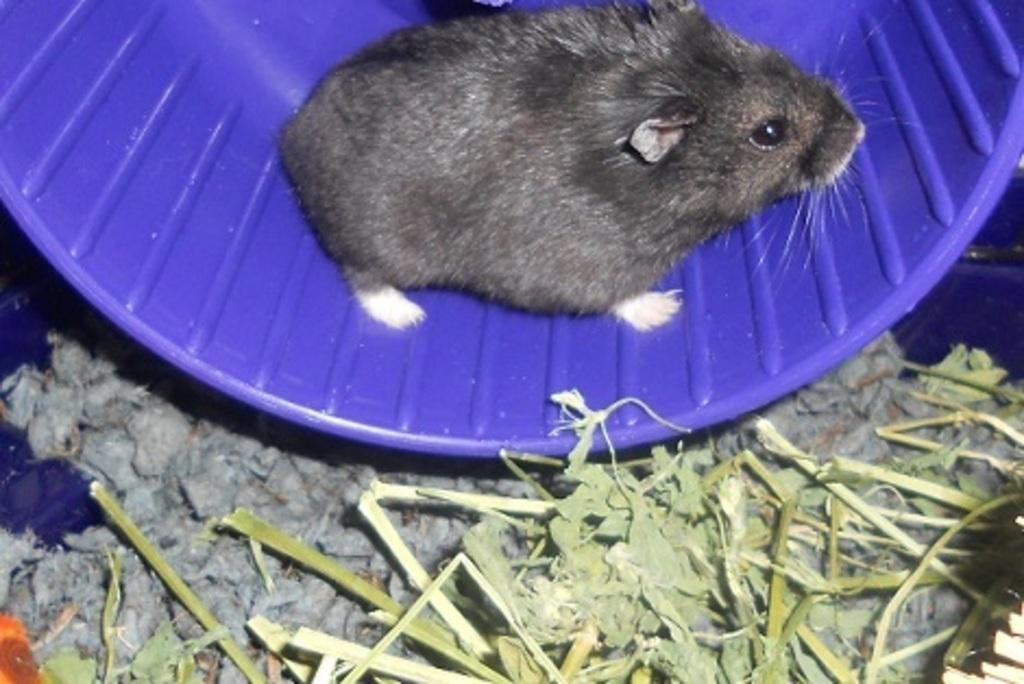Could you give a brief overview of what you see in this image? In the image there is a rat on the purple surface and there is some grass beside the rat. 